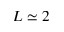<formula> <loc_0><loc_0><loc_500><loc_500>L \simeq 2</formula> 